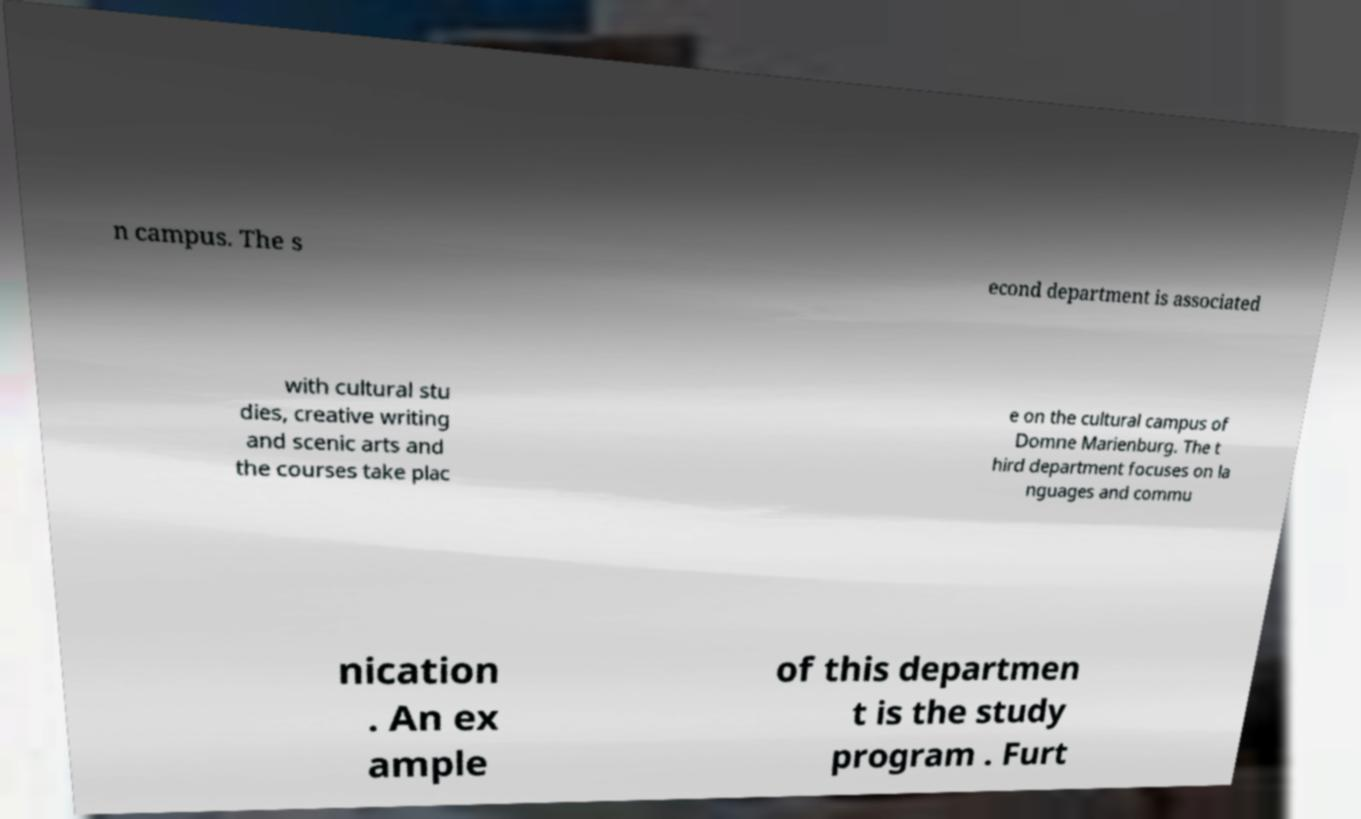Please identify and transcribe the text found in this image. n campus. The s econd department is associated with cultural stu dies, creative writing and scenic arts and the courses take plac e on the cultural campus of Domne Marienburg. The t hird department focuses on la nguages and commu nication . An ex ample of this departmen t is the study program . Furt 